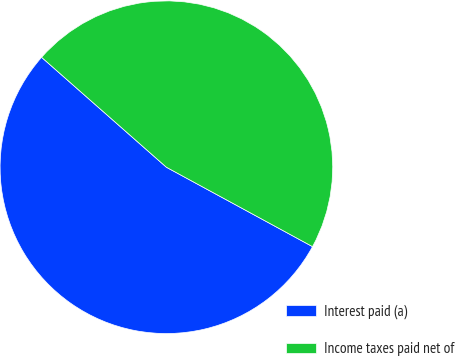Convert chart. <chart><loc_0><loc_0><loc_500><loc_500><pie_chart><fcel>Interest paid (a)<fcel>Income taxes paid net of<nl><fcel>53.57%<fcel>46.43%<nl></chart> 